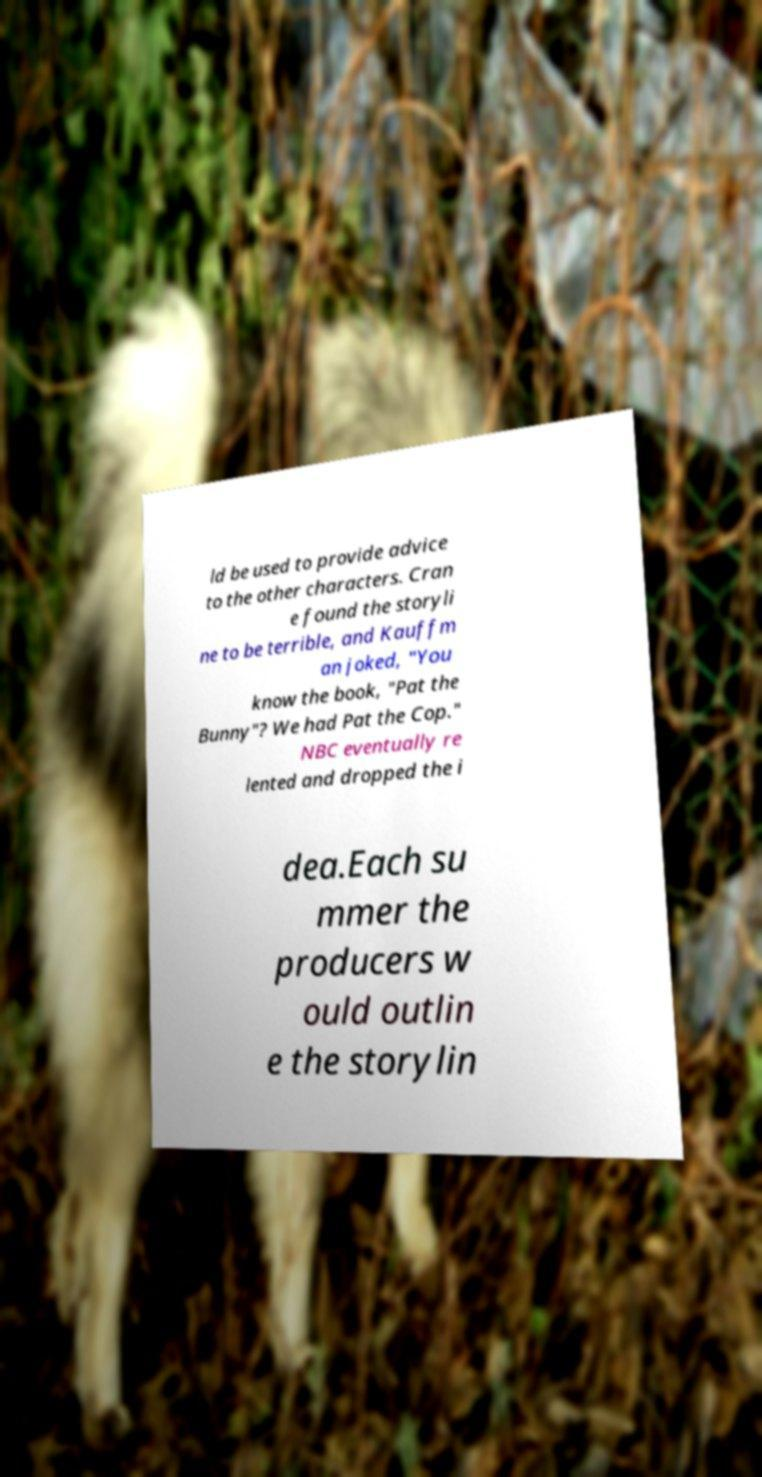Please identify and transcribe the text found in this image. ld be used to provide advice to the other characters. Cran e found the storyli ne to be terrible, and Kauffm an joked, "You know the book, "Pat the Bunny"? We had Pat the Cop." NBC eventually re lented and dropped the i dea.Each su mmer the producers w ould outlin e the storylin 